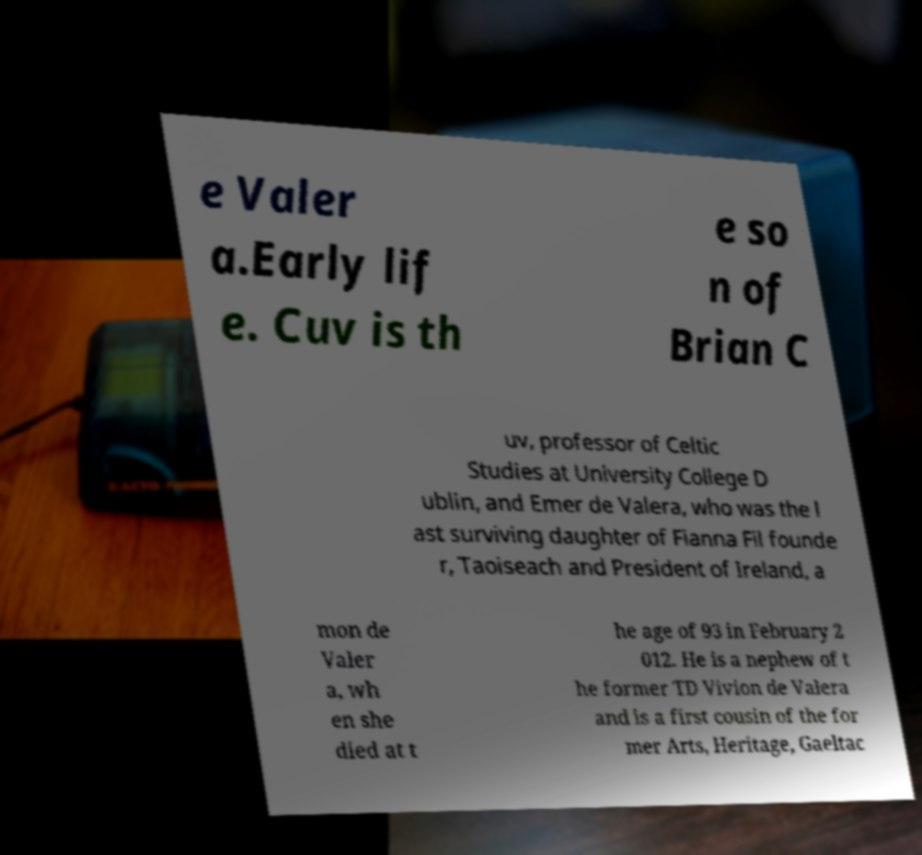Please read and relay the text visible in this image. What does it say? e Valer a.Early lif e. Cuv is th e so n of Brian C uv, professor of Celtic Studies at University College D ublin, and Emer de Valera, who was the l ast surviving daughter of Fianna Fil founde r, Taoiseach and President of Ireland, a mon de Valer a, wh en she died at t he age of 93 in February 2 012. He is a nephew of t he former TD Vivion de Valera and is a first cousin of the for mer Arts, Heritage, Gaeltac 